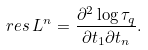<formula> <loc_0><loc_0><loc_500><loc_500>r e s \, L ^ { n } = \frac { \partial ^ { 2 } \log \tau _ { q } } { \partial t _ { 1 } \partial t _ { n } } .</formula> 